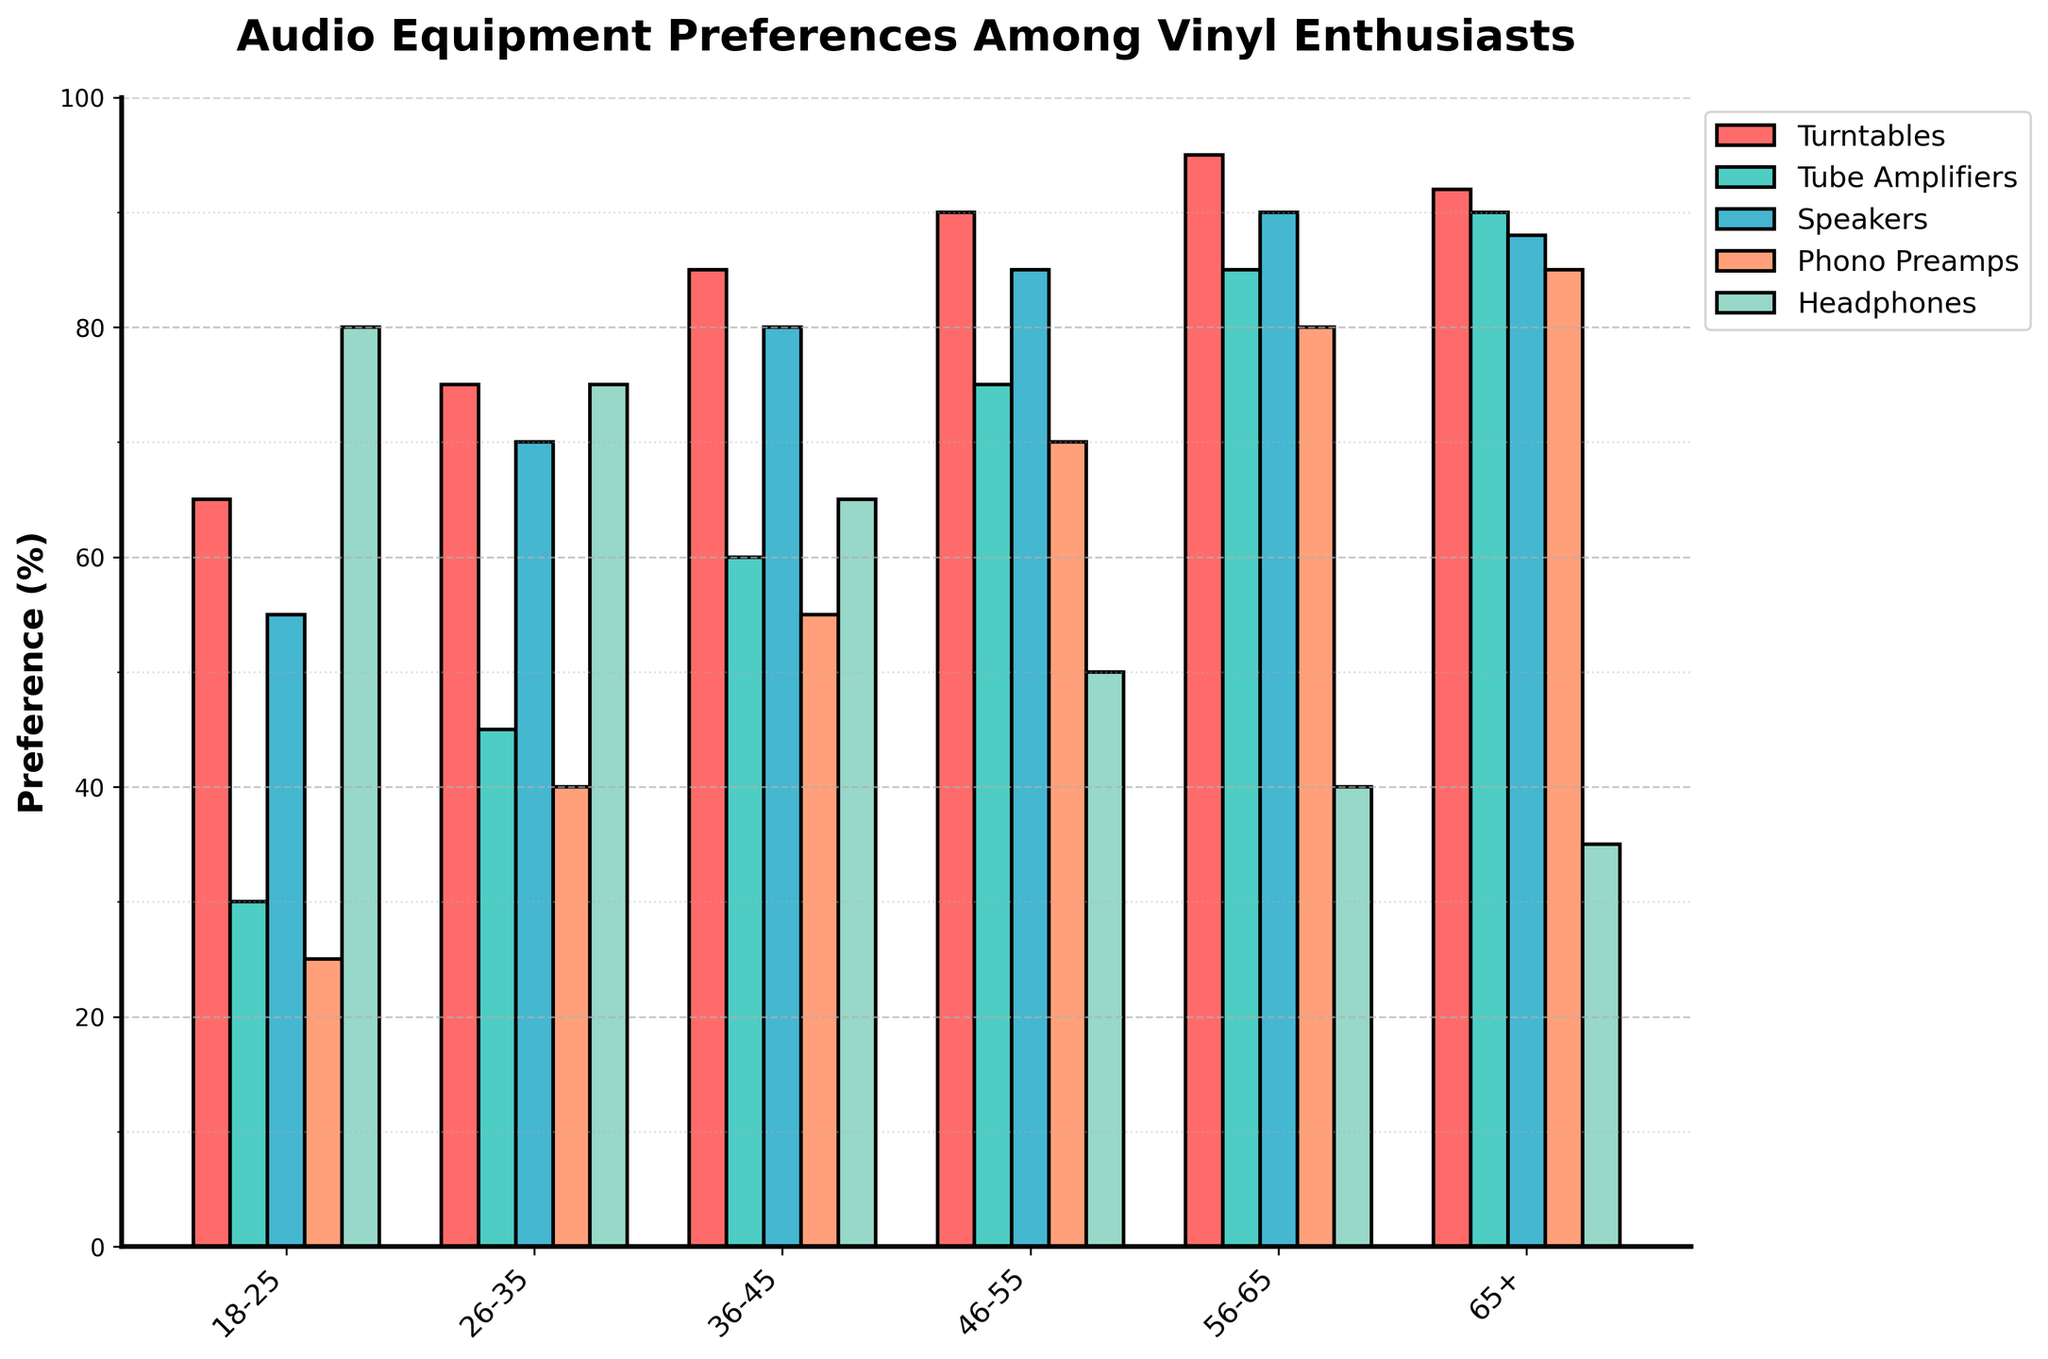What is the most preferred audio equipment among the 56-65 age group? Look at the bar that represents the 56-65 age group and identify which bar is the tallest. The tallest bar corresponds to Turntables, indicating that it is the most preferred equipment in this age group.
Answer: Turntables Which age group shows the highest preference for Tube Amplifiers? Compare the heights of the bars for Tube Amplifiers across all age groups and identify the tallest bar. The tallest bar is for the 65+ age group.
Answer: 65+ What is the average preference for Speakers across all age groups? Sum the percentage values for Speakers across all age groups: 55 + 70 + 80 + 85 + 90 + 88 = 468. Then, divide by the number of age groups (6): 468 ÷ 6 = 78.
Answer: 78 In which age group is the difference between preferences for Turntables and Headphones the greatest? Calculate the difference between the percentage values for Turntables and Headphones in each age group, and identify the age group with the largest result. For example, for 18-25: 65 - 80 = -15; for 56-65: 95 - 40 = 55. The greatest difference is in the 56-65 age group.
Answer: 56-65 How does the preference for Turntables in the 46-55 age group compare to the preference for Turntables in the 65+ age group? Compare the heights of the bars representing Turntables in the 46-55 and 65+ age groups. The bar for 46-55 is 90, while the bar for 65+ is 92.
Answer: Less Which audio equipment has the least variation in preferences across all age groups? Examine the range of values for each equipment type by subtracting the lowest value from the highest value. Identify the equipment with the smallest range. For example, Tube Amplifiers range from 30 to 90, giving a range of 60, and so on. Speakers have the least variation with a range of 35 (55 to 90).
Answer: Speakers How many percentage points higher is the preference for Phono Preamps in the 36-45 age group compared to the 18-25 age group? Subtract the percentage value for Phono Preamps in the 18-25 age group from the value in the 36-45 age group: 55 - 25 = 30.
Answer: 30 Which equipment type shows a decreasing trend in preference as the age groups get younger? Look for a trend where the bar heights decrease from older to younger age groups. The preference for Tube Amplifiers decreases from 90 (65+) down to 30 (18-25).
Answer: Tube Amplifiers What is the combined preference for Headphones across the 26-35 and 46-55 age groups? Sum the percentage values for Headphones in the 26-35 and 46-55 age groups: 75 + 50 = 125.
Answer: 125 